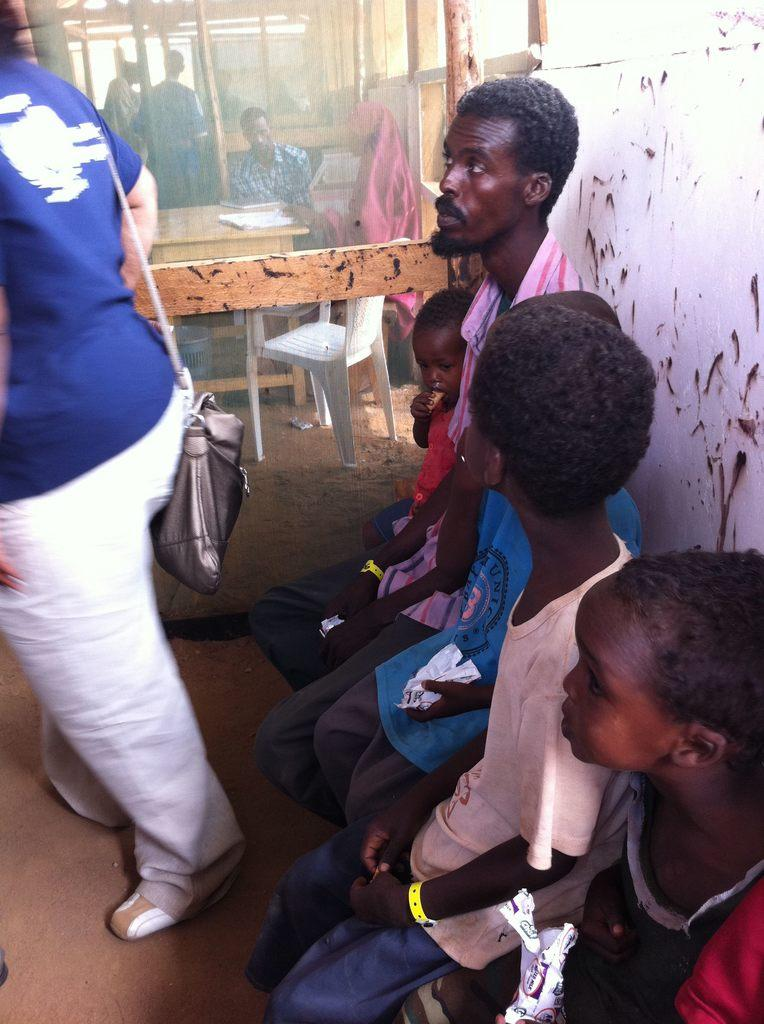How are the persons in the image positioned? There are persons standing and sitting in the image. What is the purpose of the empty chair in the image? The empty chair may be available for someone to sit or may be part of the setting. What is on the table in the image? There is a table with papers on it in the image. What type of soup is being served in the bucket in the image? There is no soup or bucket present in the image. 